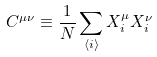Convert formula to latex. <formula><loc_0><loc_0><loc_500><loc_500>C ^ { \mu \nu } \equiv \frac { 1 } { N } \sum _ { \langle i \rangle } X _ { i } ^ { \mu } X _ { i } ^ { \nu }</formula> 